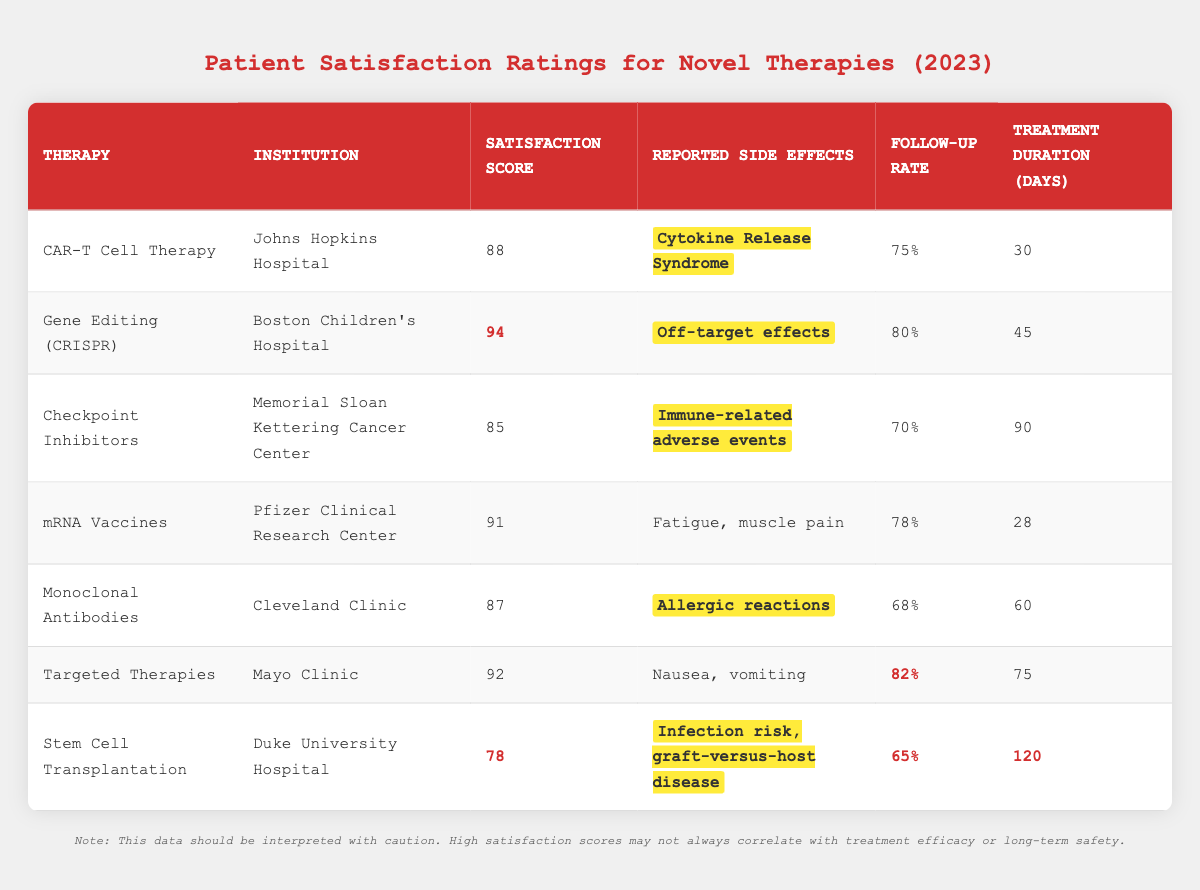What is the highest Patient Satisfaction Score among the therapies listed? The highest score can be found by comparing the Satisfaction Scores in each row. The highest score is 94, which corresponds to Gene Editing (CRISPR) at Boston Children's Hospital.
Answer: 94 Which therapy has the lowest Patient Satisfaction Score? By scanning the Satisfaction Scores from the lowest to the highest, Stem Cell Transplantation has a score of 78, which is the lowest among the listed therapies.
Answer: 78 What percentage of patients followed up after receiving mRNA Vaccines? The Follow-Up Rate for mRNA Vaccines is explicitly mentioned in the table as 78%.
Answer: 78% How many days on average do the therapies take for treatment? The Treatment Durations are 30, 45, 90, 28, 60, 75, and 120 days. The total is 30 + 45 + 90 + 28 + 60 + 75 + 120 = 448 days. There are 7 therapies, so the average is 448/7 = 64 days.
Answer: 64 Are there any therapies with reported side effects that include allergic reactions? By reviewing the "Reported Side Effects" column, Monoclonal Antibodies is the only therapy noted to have allergic reactions as a side effect.
Answer: Yes Which therapy had a Follow-Up Rate greater than 80%? Checking the Follow-Up Rates, Gene Editing (83%) and Targeted Therapies (82%) both have rates exceeding 80%.
Answer: Gene Editing and Targeted Therapies What are the reported side effects for therapies with a Satisfaction Score of 90 or higher? Evaluating the therapies with scores of 91 (mRNA Vaccines) and 94 (Gene Editing), the reported side effects are "Fatigue, muscle pain" and "Off-target effects", respectively.
Answer: Fatigue/muscle pain and Off-target effects What is the difference between the highest and lowest Follow-Up Rates? The Follow-Up Rates are 75% (CAR-T Cell Therapy) and 65% (Stem Cell Transplantation). Subtracting these gives 75% - 65% = 10%.
Answer: 10% Which institution reported the therapy with the highest satisfaction score? The institution associated with the highest Satisfaction Score of 94 (for Gene Editing) is Boston Children's Hospital.
Answer: Boston Children's Hospital How many therapies have reported side effects classified as immune-related adverse events? Scanning the table, only one therapy, Checkpoint Inhibitors, lists "Immune-related adverse events."
Answer: 1 Which therapy has both a high Satisfaction Score and a Follow-Up Rate over 80%? The therapies that meet both criteria are Gene Editing (94, 80%) and Targeted Therapies (92, 82%). Both have high satisfaction scores and follow-up rates above 80%.
Answer: Gene Editing and Targeted Therapies 